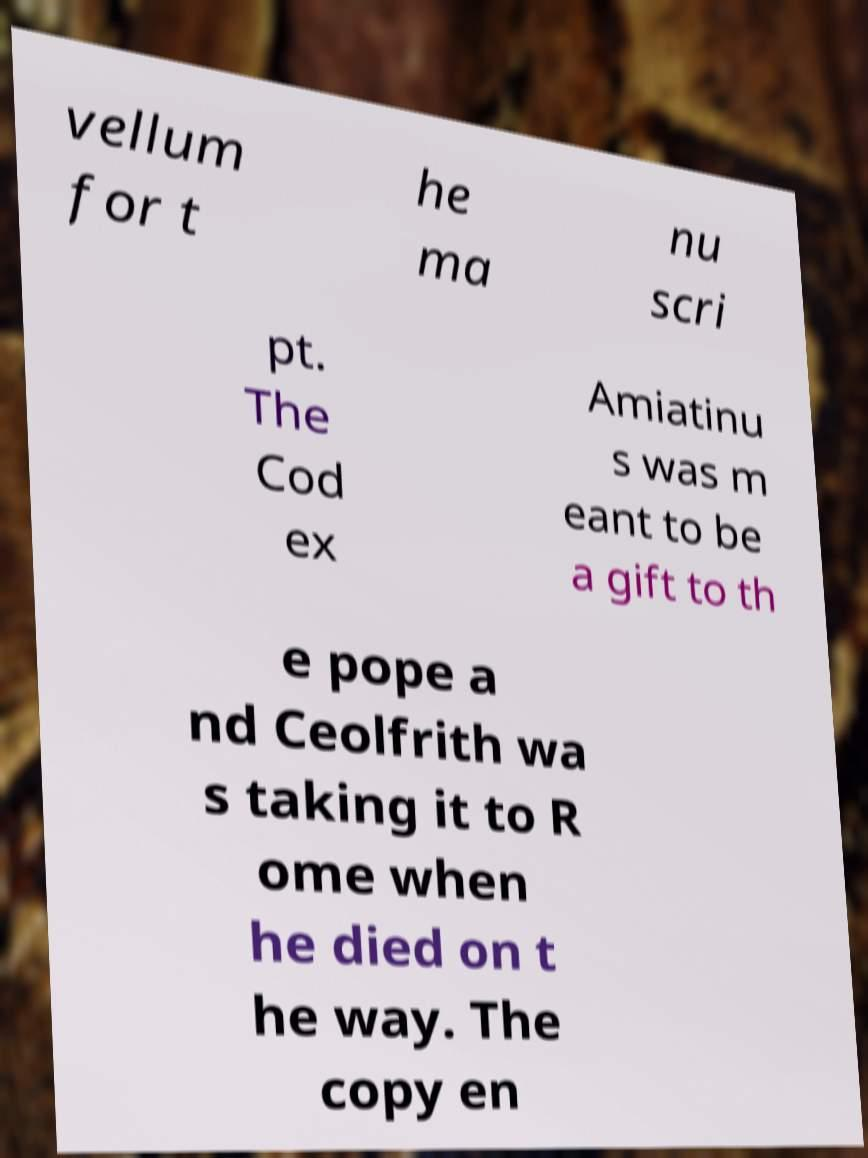Can you read and provide the text displayed in the image?This photo seems to have some interesting text. Can you extract and type it out for me? vellum for t he ma nu scri pt. The Cod ex Amiatinu s was m eant to be a gift to th e pope a nd Ceolfrith wa s taking it to R ome when he died on t he way. The copy en 